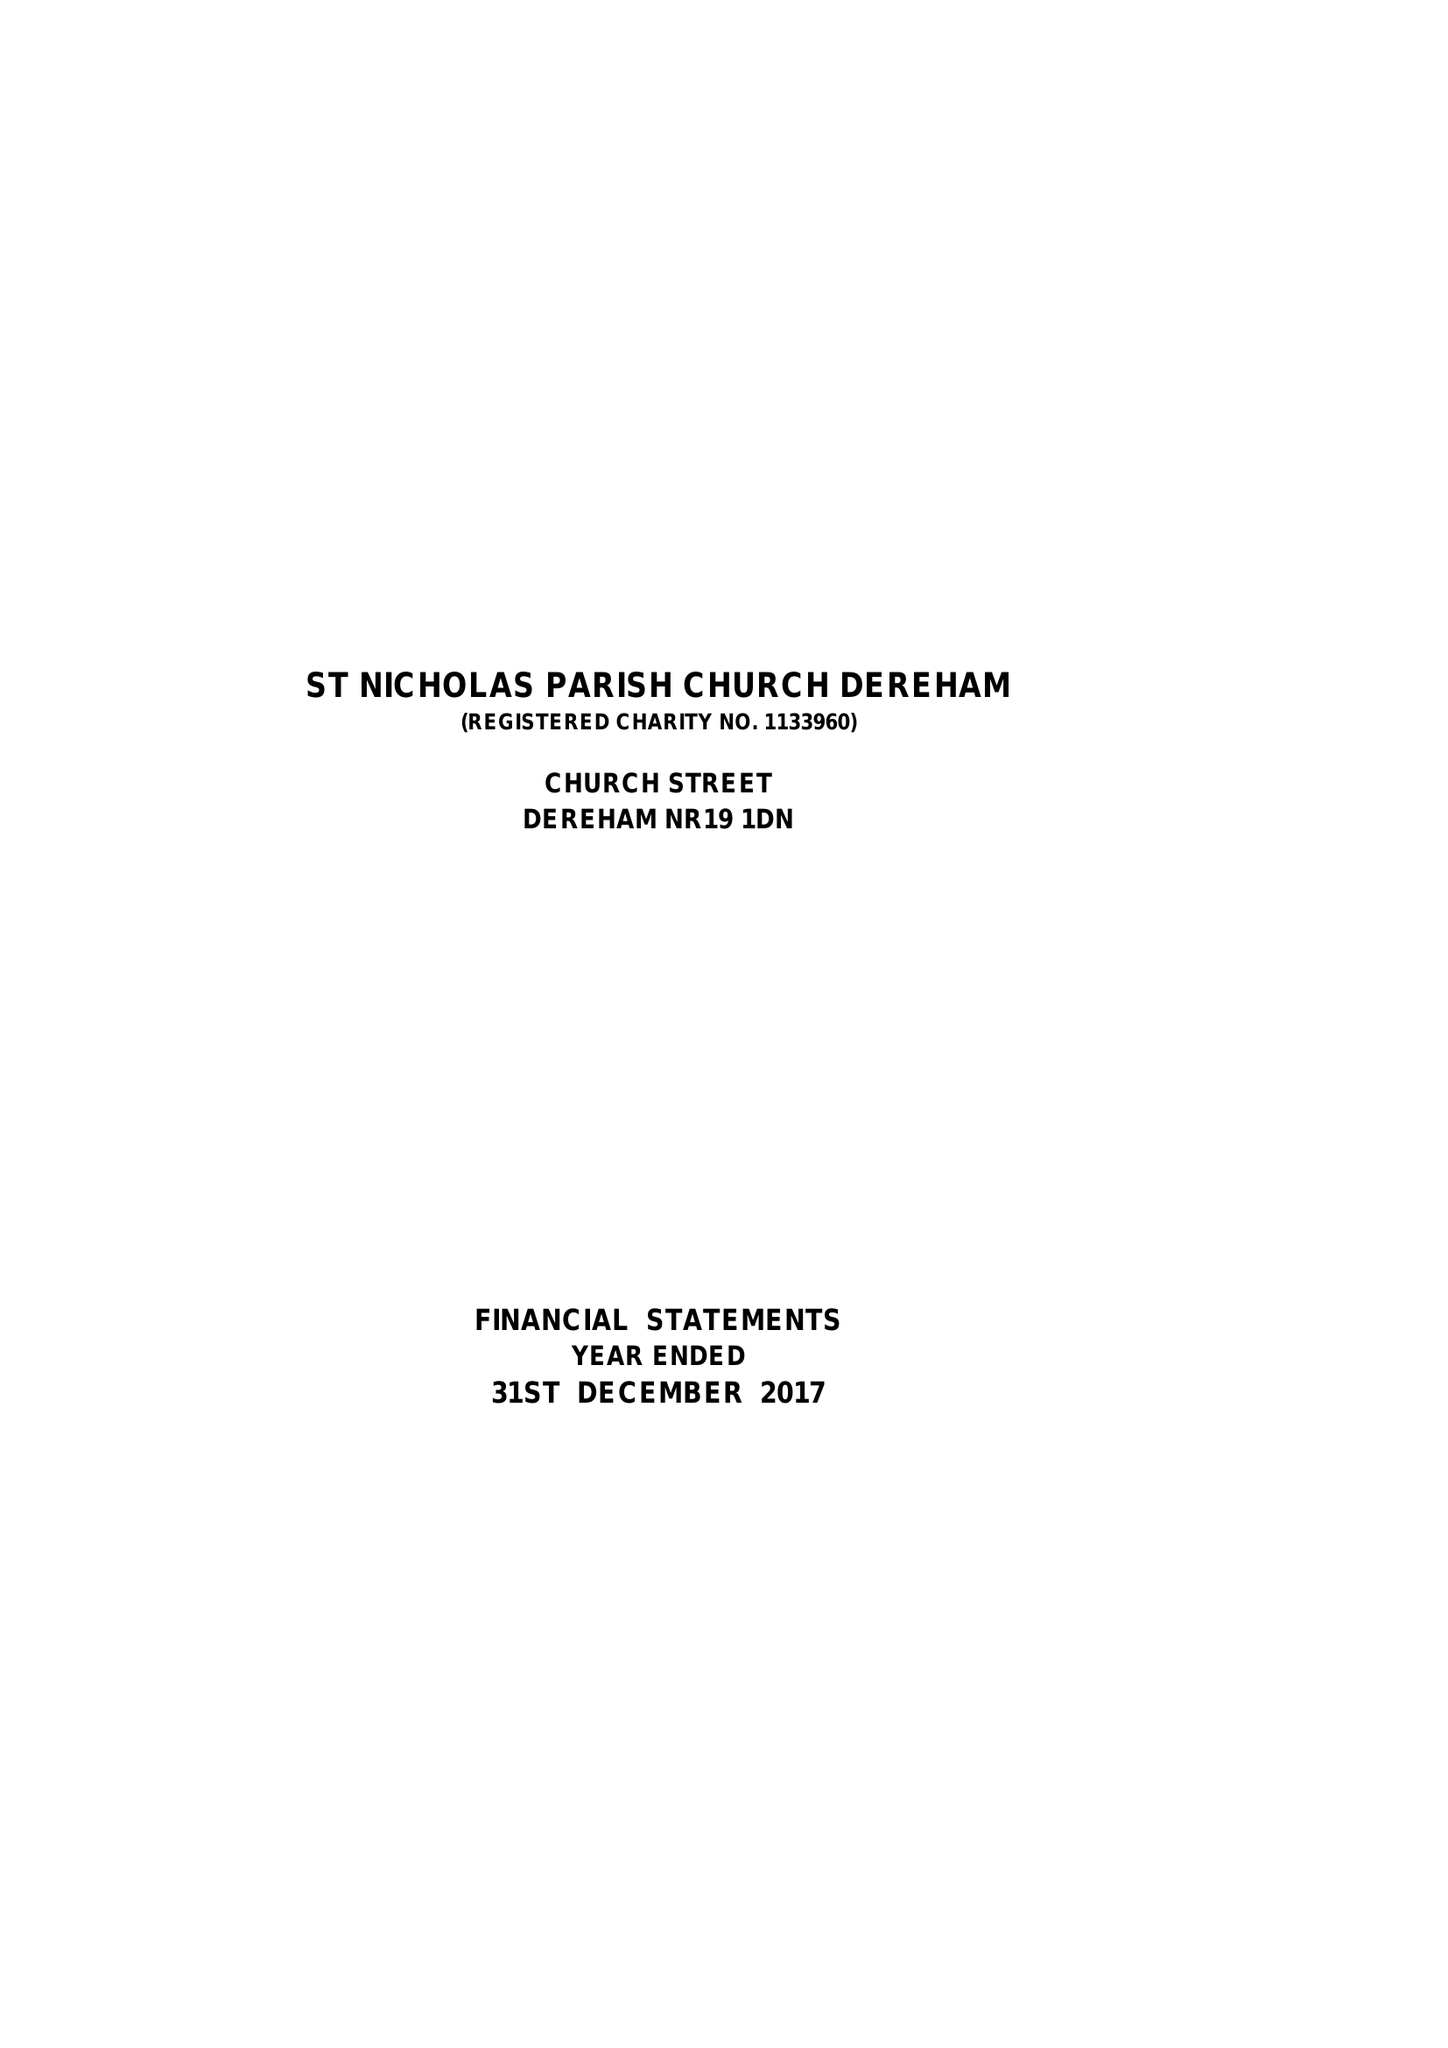What is the value for the charity_number?
Answer the question using a single word or phrase. 1133960 